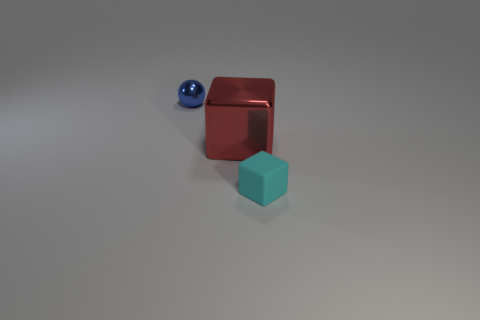Can you describe the composition of the image and what it might imply? The image composition consists of three objects of varying colors and sizes placed in the lower left quadrant, creating a sense of negative space throughout the rest of the scene. This could imply a minimalist or abstract aesthetic, possibly symbolizing simplicity, or an intention to focus on the forms and colors of the objects themselves without distraction. 